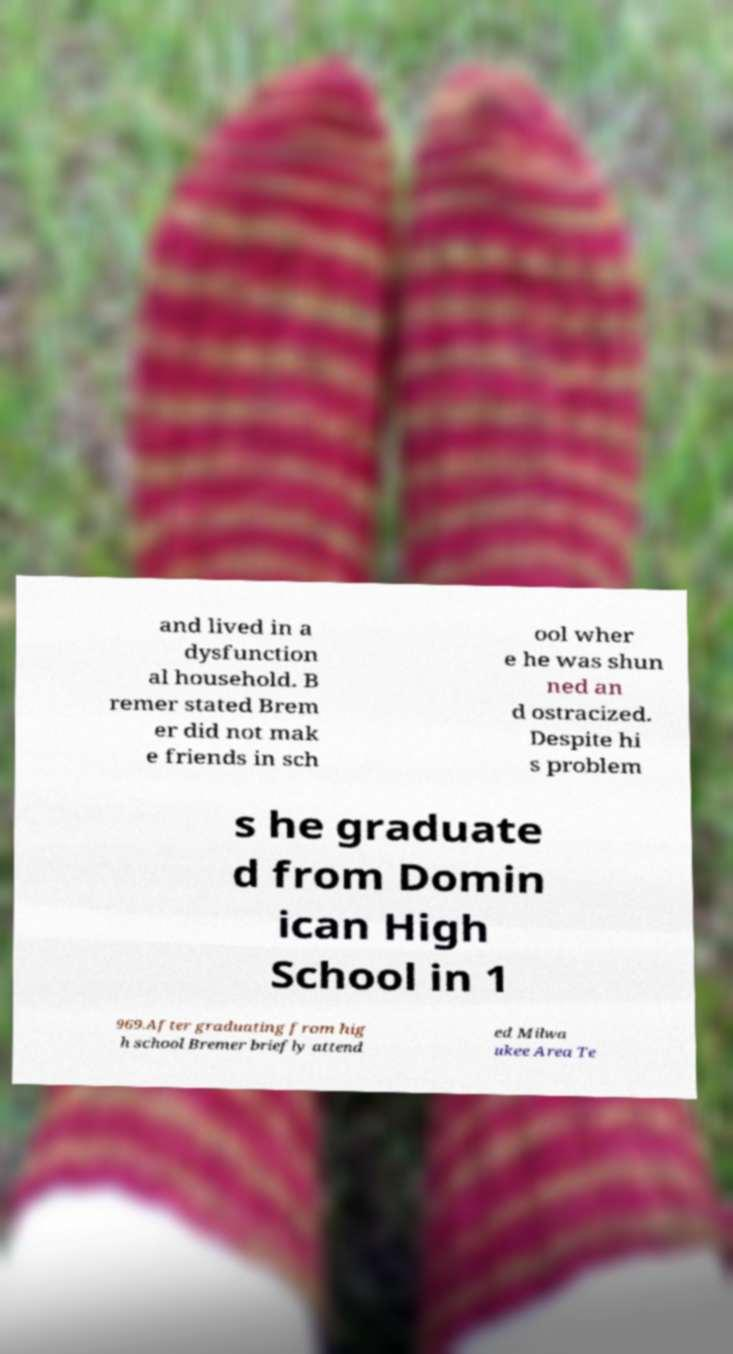There's text embedded in this image that I need extracted. Can you transcribe it verbatim? and lived in a dysfunction al household. B remer stated Brem er did not mak e friends in sch ool wher e he was shun ned an d ostracized. Despite hi s problem s he graduate d from Domin ican High School in 1 969.After graduating from hig h school Bremer briefly attend ed Milwa ukee Area Te 